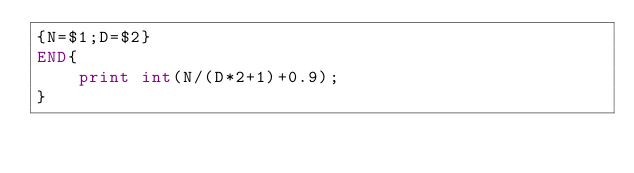<code> <loc_0><loc_0><loc_500><loc_500><_Awk_>{N=$1;D=$2}
END{
	print int(N/(D*2+1)+0.9);
}</code> 